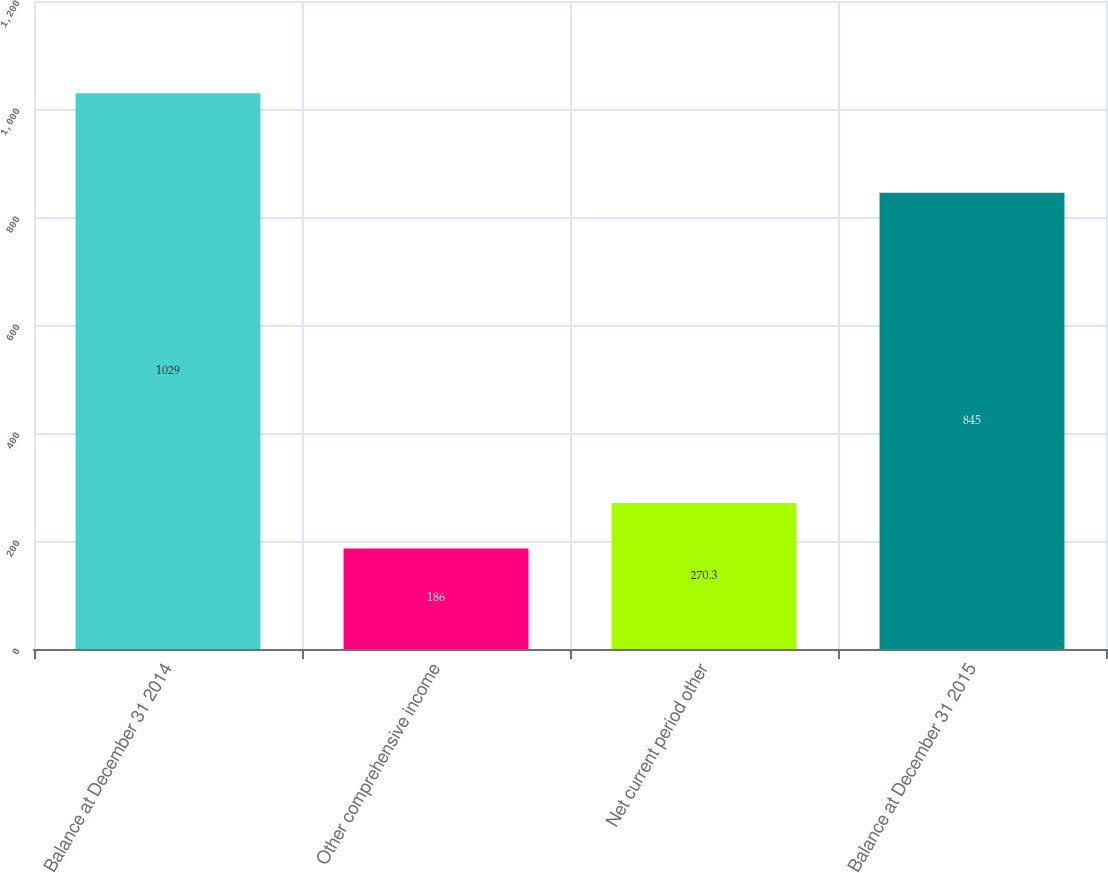Convert chart to OTSL. <chart><loc_0><loc_0><loc_500><loc_500><bar_chart><fcel>Balance at December 31 2014<fcel>Other comprehensive income<fcel>Net current period other<fcel>Balance at December 31 2015<nl><fcel>1029<fcel>186<fcel>270.3<fcel>845<nl></chart> 